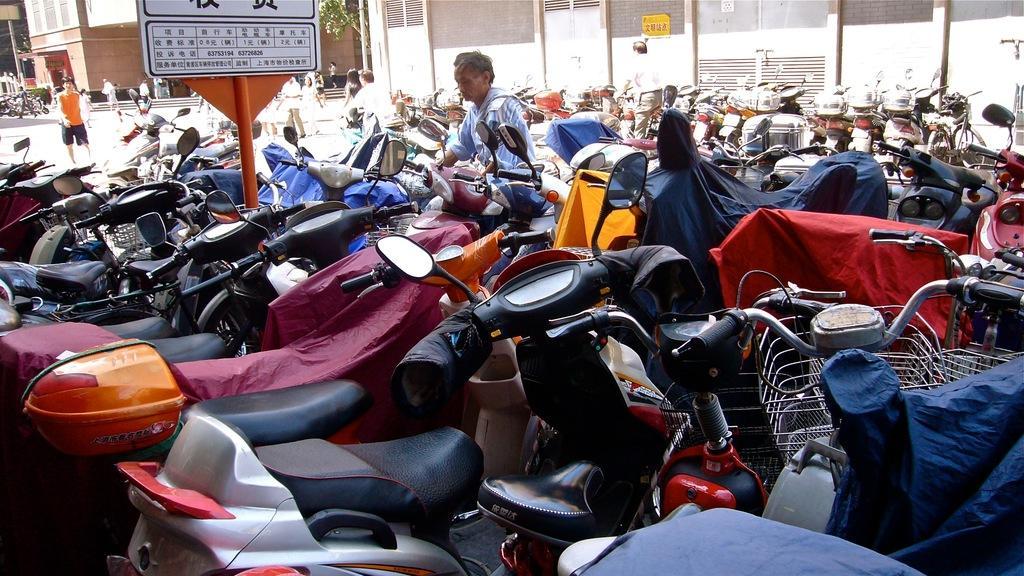Could you give a brief overview of what you see in this image? This image is taken outdoors. In the background there are a few buildings. There is a tree. There are two poles. A few people are walking and there are a few stairs. In the middle of the image many bikes are parked on the ground and there is a man. There is a board with a text on it. 